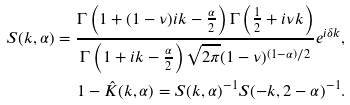<formula> <loc_0><loc_0><loc_500><loc_500>S ( k , \alpha ) = \frac { \Gamma \left ( 1 + ( 1 - \nu ) i k - \frac { \alpha } { 2 } \right ) \Gamma \left ( \frac { 1 } { 2 } + i \nu k \right ) } { \Gamma \left ( 1 + i k - \frac { \alpha } { 2 } \right ) \sqrt { 2 \pi } ( 1 - \nu ) ^ { ( 1 - \alpha ) / 2 } } e ^ { i \delta k } , \\ 1 - \hat { K } ( k , \alpha ) = S ( k , \alpha ) ^ { - 1 } S ( - k , 2 - \alpha ) ^ { - 1 } .</formula> 